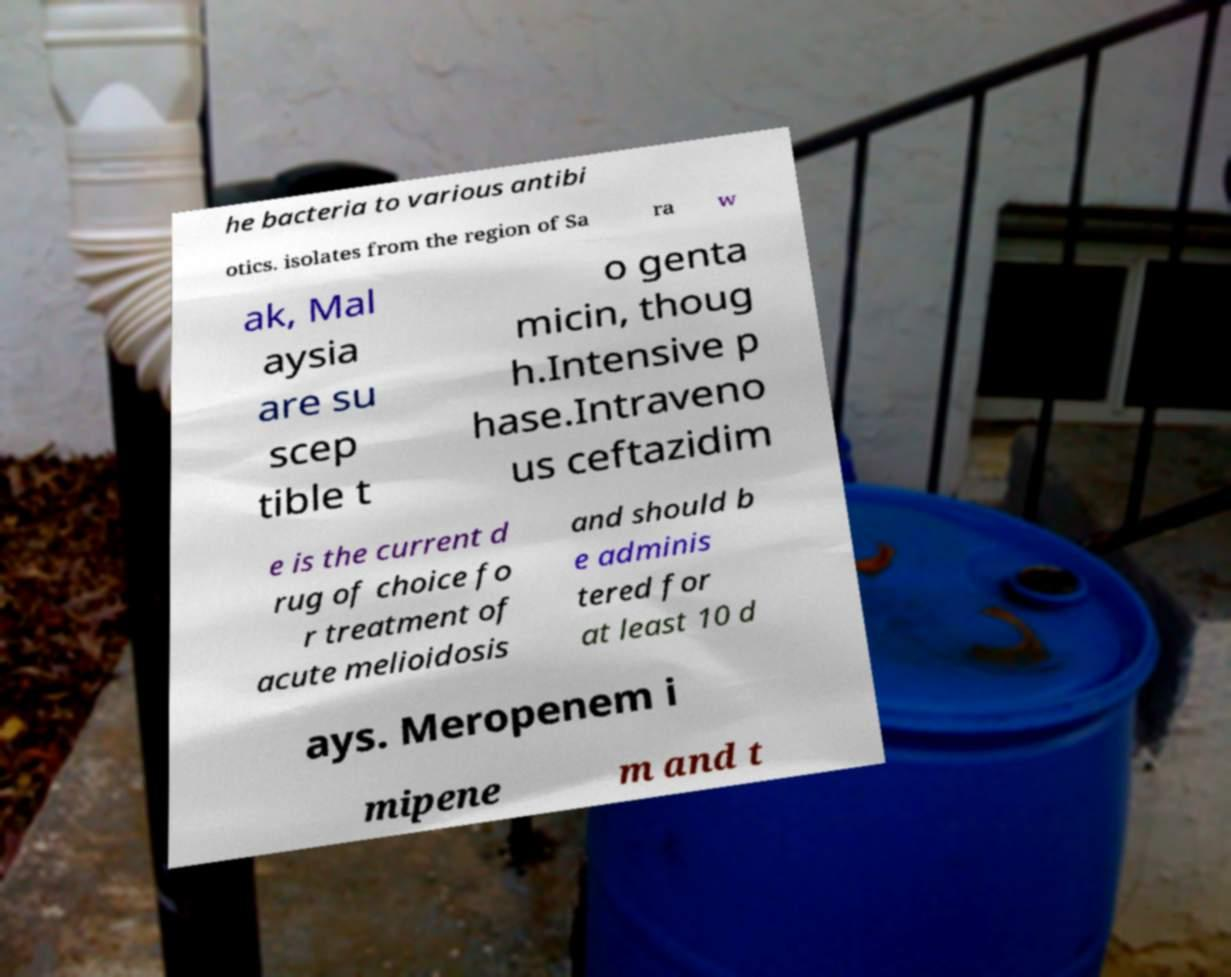Can you accurately transcribe the text from the provided image for me? he bacteria to various antibi otics. isolates from the region of Sa ra w ak, Mal aysia are su scep tible t o genta micin, thoug h.Intensive p hase.Intraveno us ceftazidim e is the current d rug of choice fo r treatment of acute melioidosis and should b e adminis tered for at least 10 d ays. Meropenem i mipene m and t 